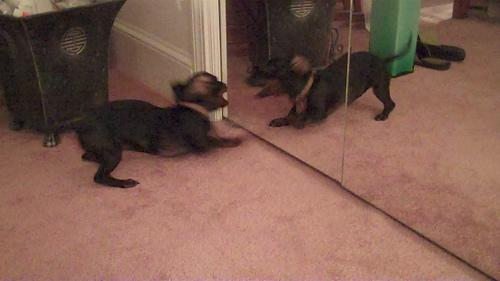Enumerate three objects in the image that can be found near the dog. A decorative metal trash can, a piece of furniture, and a green bag. Analyze the interaction between the dog and the mirror in terms of the dog's possible emotions or intentions. The dog is barking at its reflection, which could indicate curiosity or surprise upon seeing its own reflection in the mirror. What is the main interaction happening between the dog and the mirror? The dog is barking at its reflection in the mirror. What is the primary action taking place in the image? A dog is barking at a mirror in a room with a pink carpet. Provide a concise summary of the image, including the most noticeable elements. A small black and brown dog with a collar is barking at its reflection in a large mirror in a room with a bright pink carpet. What type of collar does the dog wear, and what colors does it have? The dog wears a light brown collar with red and pink decorations. Explain the composition of the image involving the largest objects. The image features a large mirror covering sliding glass doors in a room with a bright pink carpet and a barking dog in front of the mirror. Can you identify the primary color of the floor in the image? The floor is primarily pink, covered by a bright pink carpet. How would you rate the visual content of the image to evoke positive or negative emotions? Choose between very positive, positive, neutral, negative, and very negative. Neutral. Is the dog wearing a blue collar? The caption mentions a "red and pink dog collar" and "light brown collar," but there is no mention of a blue collar. Can you spot the orange trash container? The captions mention a "decorative metal trash can" and "the trash container is black," but there is no mention of an orange trash container in the captions. Does the floor have a blue carpet? The captions mention a "bright pink carpet" and "floor is pink," but there is no mention of a blue carpet on the floor. Are there wooden doors in the room? The captions mention a "mirror covered sliding door" and "glass doors in a room," but there is no mention of wooden doors in the room. Is there a small white dog in the image? The captions mention a "small black and brown dog" and "dog is dark brown," but there is no mention of a small white dog. Can you see a large yellow bag in the reflection? The captions mention a "green bag" and "reflection of a green object in a mirror," but there is no mention of a large yellow bag in the reflection. 